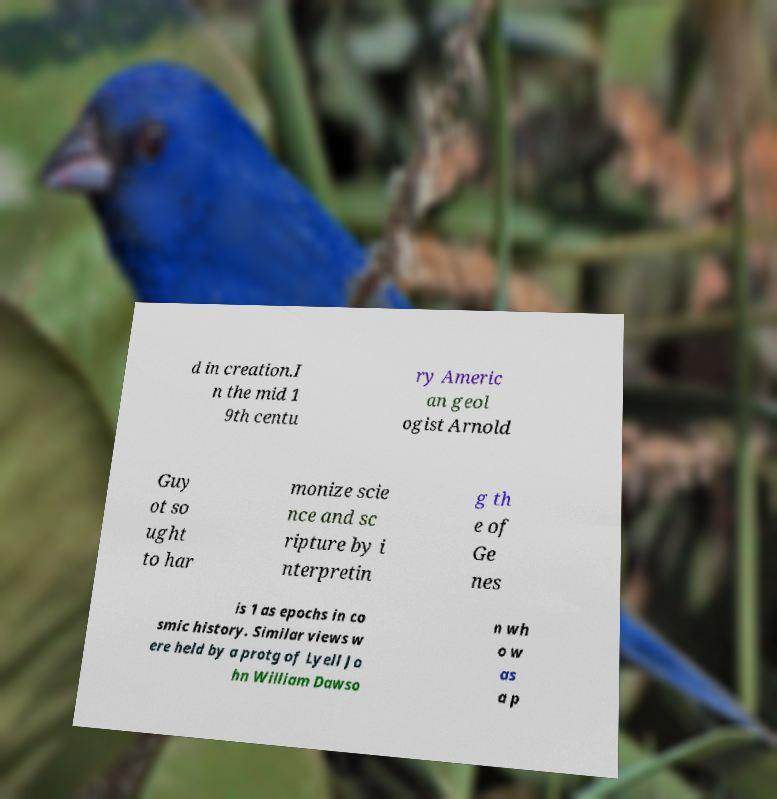Please identify and transcribe the text found in this image. d in creation.I n the mid 1 9th centu ry Americ an geol ogist Arnold Guy ot so ught to har monize scie nce and sc ripture by i nterpretin g th e of Ge nes is 1 as epochs in co smic history. Similar views w ere held by a protg of Lyell Jo hn William Dawso n wh o w as a p 